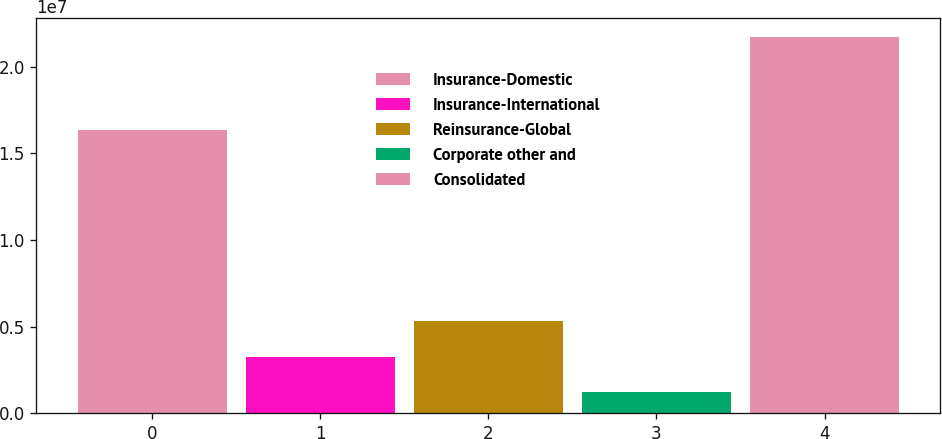Convert chart. <chart><loc_0><loc_0><loc_500><loc_500><bar_chart><fcel>Insurance-Domestic<fcel>Insurance-International<fcel>Reinsurance-Global<fcel>Corporate other and<fcel>Consolidated<nl><fcel>1.63517e+07<fcel>3.2764e+06<fcel>5.32691e+06<fcel>1.2259e+06<fcel>2.1731e+07<nl></chart> 